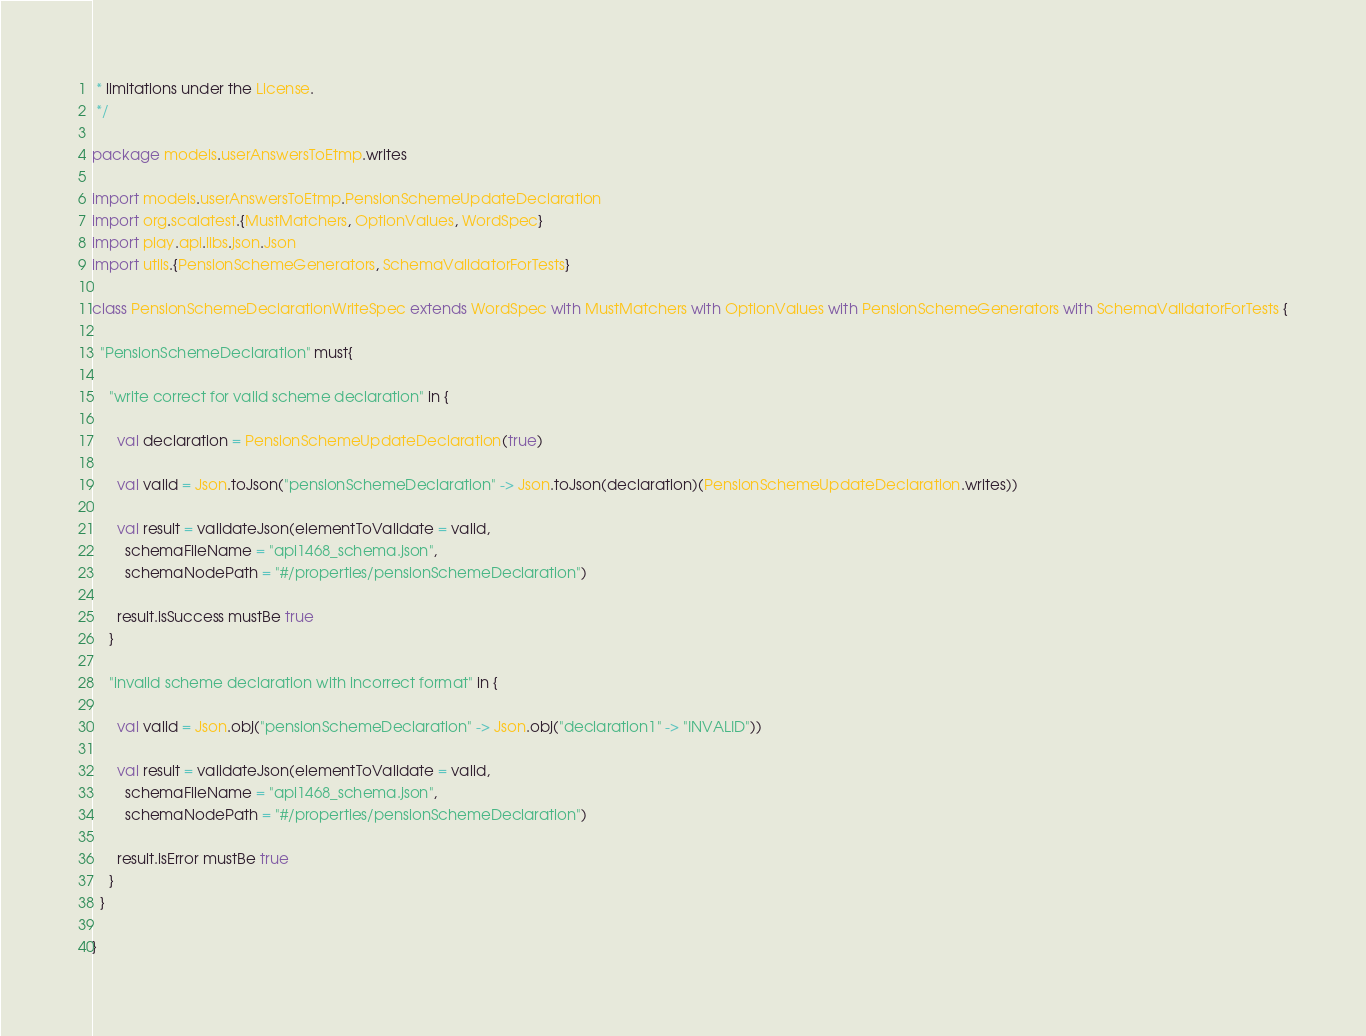<code> <loc_0><loc_0><loc_500><loc_500><_Scala_> * limitations under the License.
 */

package models.userAnswersToEtmp.writes

import models.userAnswersToEtmp.PensionSchemeUpdateDeclaration
import org.scalatest.{MustMatchers, OptionValues, WordSpec}
import play.api.libs.json.Json
import utils.{PensionSchemeGenerators, SchemaValidatorForTests}

class PensionSchemeDeclarationWriteSpec extends WordSpec with MustMatchers with OptionValues with PensionSchemeGenerators with SchemaValidatorForTests {

  "PensionSchemeDeclaration" must{

    "write correct for valid scheme declaration" in {

      val declaration = PensionSchemeUpdateDeclaration(true)

      val valid = Json.toJson("pensionSchemeDeclaration" -> Json.toJson(declaration)(PensionSchemeUpdateDeclaration.writes))

      val result = validateJson(elementToValidate = valid,
        schemaFileName = "api1468_schema.json",
        schemaNodePath = "#/properties/pensionSchemeDeclaration")

      result.isSuccess mustBe true
    }

    "invalid scheme declaration with incorrect format" in {

      val valid = Json.obj("pensionSchemeDeclaration" -> Json.obj("declaration1" -> "INVALID"))

      val result = validateJson(elementToValidate = valid,
        schemaFileName = "api1468_schema.json",
        schemaNodePath = "#/properties/pensionSchemeDeclaration")

      result.isError mustBe true
    }
  }

}
</code> 